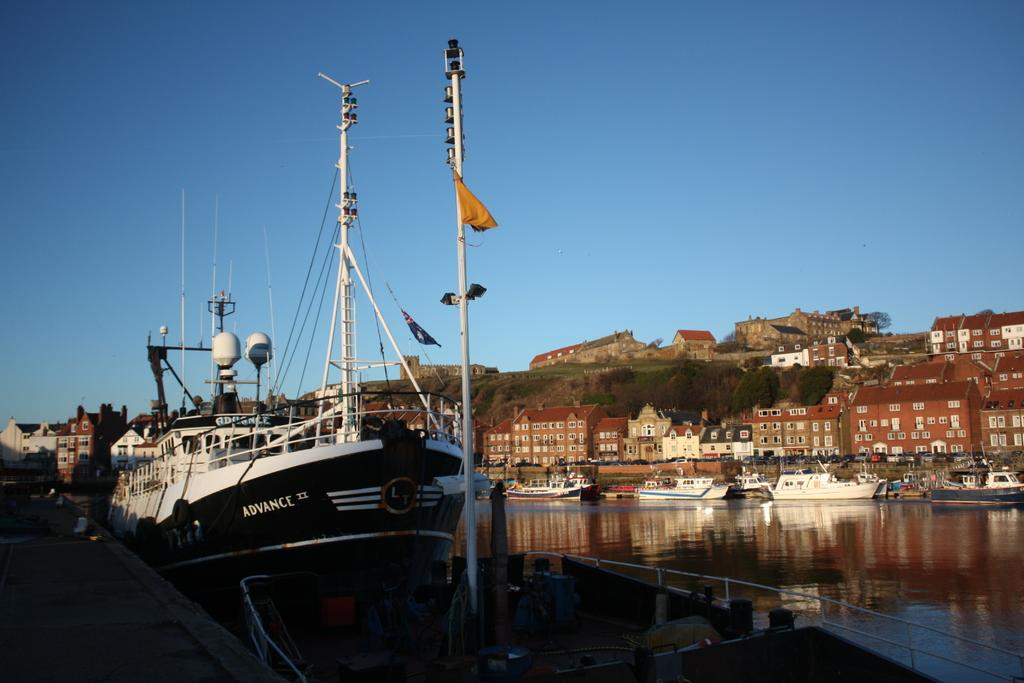What is located in the water in the image? There are ships in the water in the image. What can be seen at the right side of the image? There are buildings and trees at the right side of the image. What is visible in the background of the image? The sky is visible in the background of the image. What type of jar can be seen floating in the water in the image? There is no jar present in the image; it features ships in the water. What type of sea creatures can be seen swimming near the ships in the image? There is no mention of sea creatures in the image; it only shows ships in the water. 